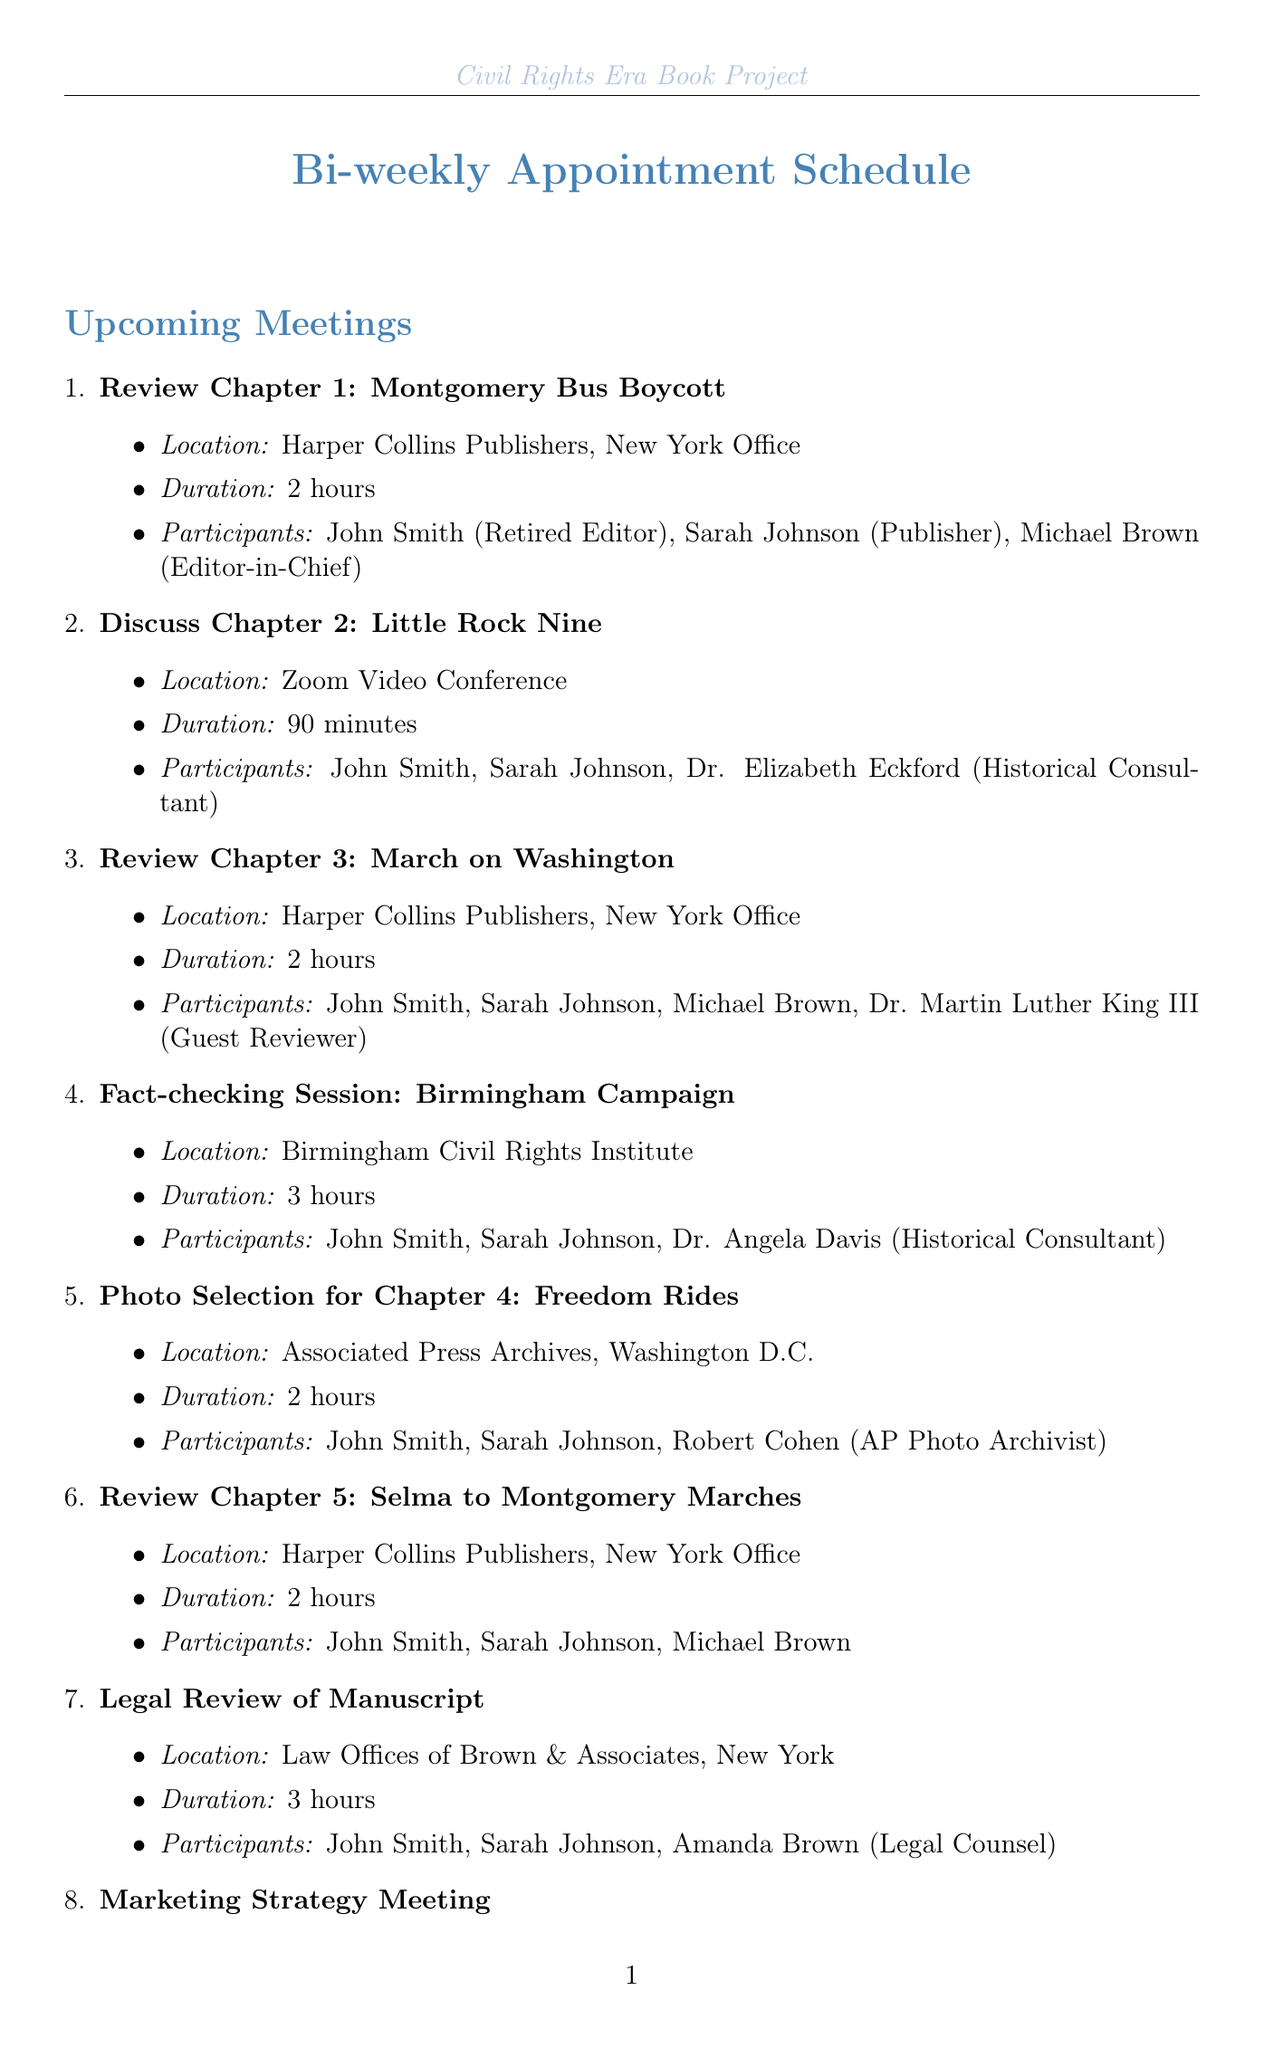what is the title of the first meeting? The title of the first meeting is the initial entry in the scheduled meetings list, which is "Review Chapter 1: Montgomery Bus Boycott."
Answer: Review Chapter 1: Montgomery Bus Boycott how long is the 'Final Manuscript Review' scheduled for? The duration of the 'Final Manuscript Review' is indicated in the meeting details, which states it takes 4 hours.
Answer: 4 hours who is the historical consultant for the 'Discuss Chapter 2: Little Rock Nine' meeting? This information is found in the participant list for that meeting, which names Dr. Elizabeth Eckford as the historical consultant.
Answer: Dr. Elizabeth Eckford how many participants are involved in the 'Photo Selection for Chapter 4: Freedom Rides'? The number of participants is the count listed under that meeting, which includes John Smith, Sarah Johnson, and Robert Cohen, totaling three participants.
Answer: 3 participants which location hosts the 'Legal Review of Manuscript'? The location is specified in the meeting details; for the 'Legal Review of Manuscript,' it is identified as the Law Offices of Brown & Associates, New York.
Answer: Law Offices of Brown & Associates, New York how many meetings are scheduled in total? The total number of meetings is the count of entries in the scheduled meetings list, which adds up to ten.
Answer: 10 what is the purpose of the meeting titled 'Marketing Strategy Meeting'? The purpose is inferred from the title, which indicates that the meeting is focused on discussing marketing strategies for the book project.
Answer: Marketing strategies for the book project what is the location for the meeting on 'Fact-checking Session: Birmingham Campaign'? The location is clearly stated in the meeting details, which indicates it takes place at the Birmingham Civil Rights Institute.
Answer: Birmingham Civil Rights Institute 